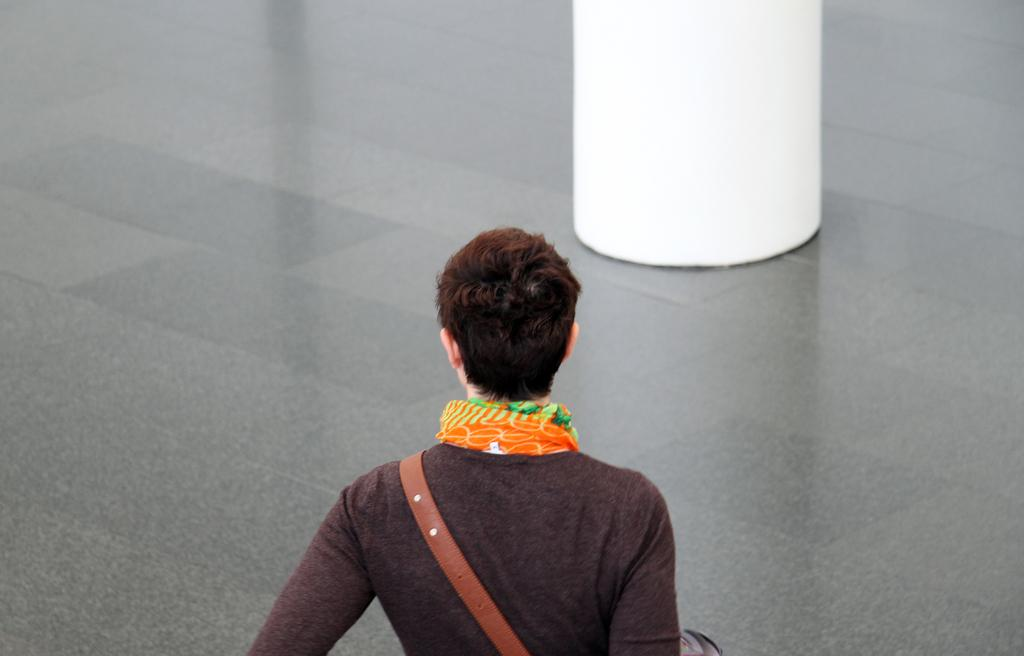Who is present in the image? There is a woman in the image. What is the woman wearing around her neck? The woman is wearing a scarf. What type of top is the woman wearing? The woman is wearing a t-shirt. What is the woman holding in the image? The woman is carrying a bag. What surface is the woman standing on? The woman is standing on the floor. What can be seen at the top of the image? There is a pillar at the top of the image. What type of attraction is the woman participating in at the beach in the image? There is no beach or attraction present in the image; it features a woman standing on the floor with a pillar in the background. 